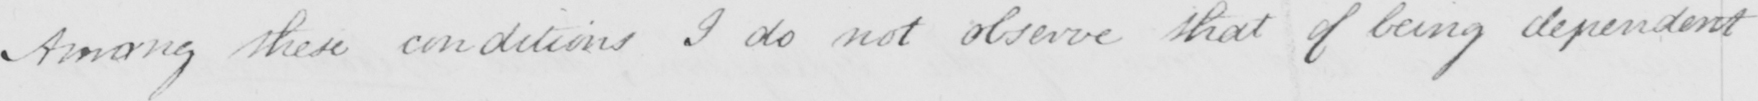Can you read and transcribe this handwriting? Among these conditions I do not observe that of being dependent 